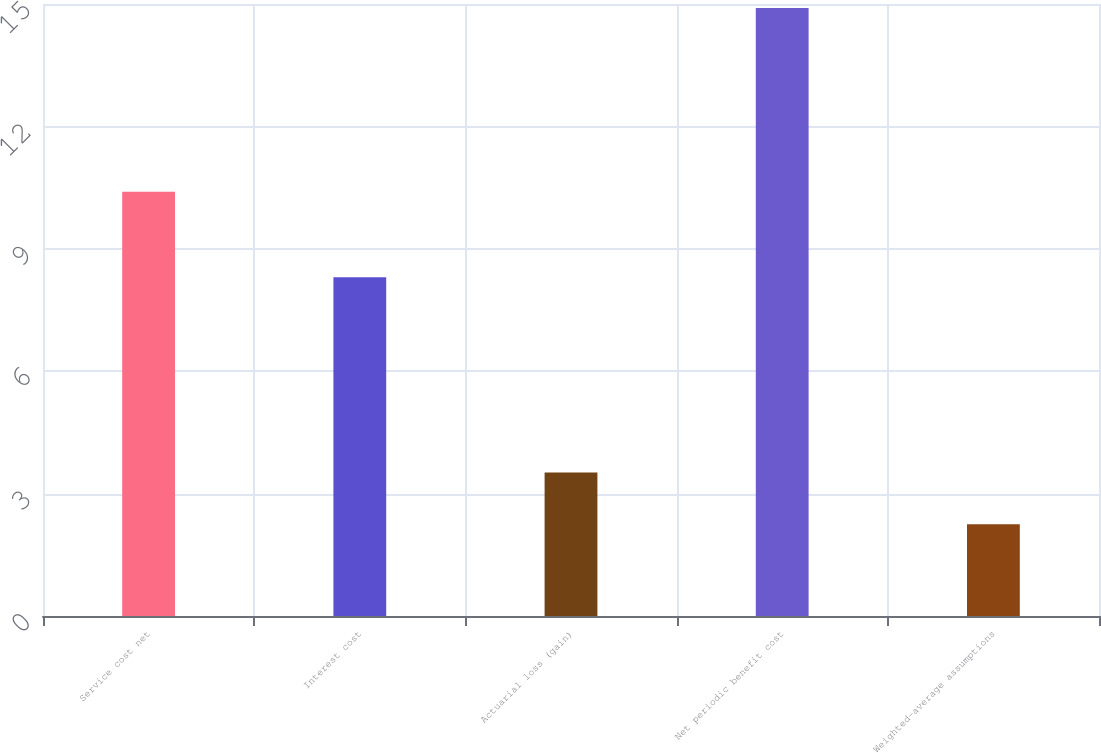Convert chart to OTSL. <chart><loc_0><loc_0><loc_500><loc_500><bar_chart><fcel>Service cost net<fcel>Interest cost<fcel>Actuarial loss (gain)<fcel>Net periodic benefit cost<fcel>Weighted-average assumptions<nl><fcel>10.4<fcel>8.3<fcel>3.52<fcel>14.9<fcel>2.25<nl></chart> 